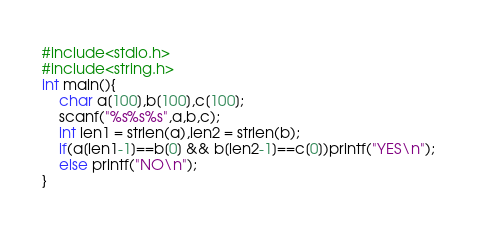Convert code to text. <code><loc_0><loc_0><loc_500><loc_500><_C_>#include<stdio.h>
#include<string.h>
int main(){
    char a[100],b[100],c[100];
    scanf("%s%s%s",a,b,c);
    int len1 = strlen(a),len2 = strlen(b);
    if(a[len1-1]==b[0] && b[len2-1]==c[0])printf("YES\n");
    else printf("NO\n");
}</code> 